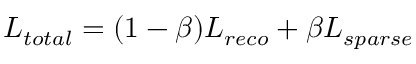<formula> <loc_0><loc_0><loc_500><loc_500>L _ { t o t a l } = ( 1 - \beta ) L _ { r e c o } + \beta L _ { s p a r s e }</formula> 